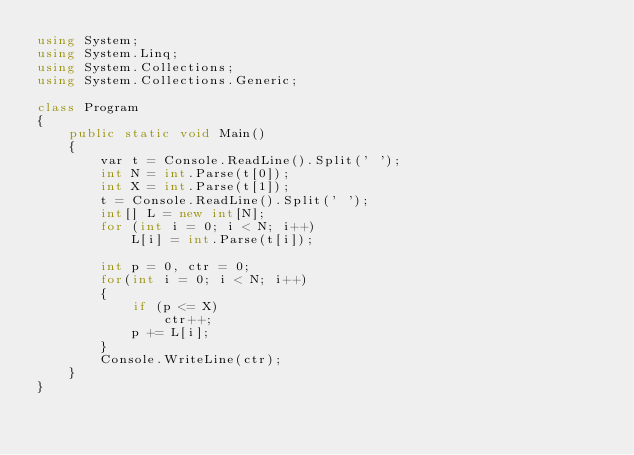Convert code to text. <code><loc_0><loc_0><loc_500><loc_500><_C#_>using System;
using System.Linq;
using System.Collections;
using System.Collections.Generic;

class Program
{
    public static void Main()
    {
        var t = Console.ReadLine().Split(' ');
        int N = int.Parse(t[0]);
        int X = int.Parse(t[1]);
        t = Console.ReadLine().Split(' ');
        int[] L = new int[N];
        for (int i = 0; i < N; i++)
            L[i] = int.Parse(t[i]);

        int p = 0, ctr = 0;
        for(int i = 0; i < N; i++)
        {
            if (p <= X)
                ctr++;
            p += L[i];
        }
        Console.WriteLine(ctr);
    }
}
</code> 